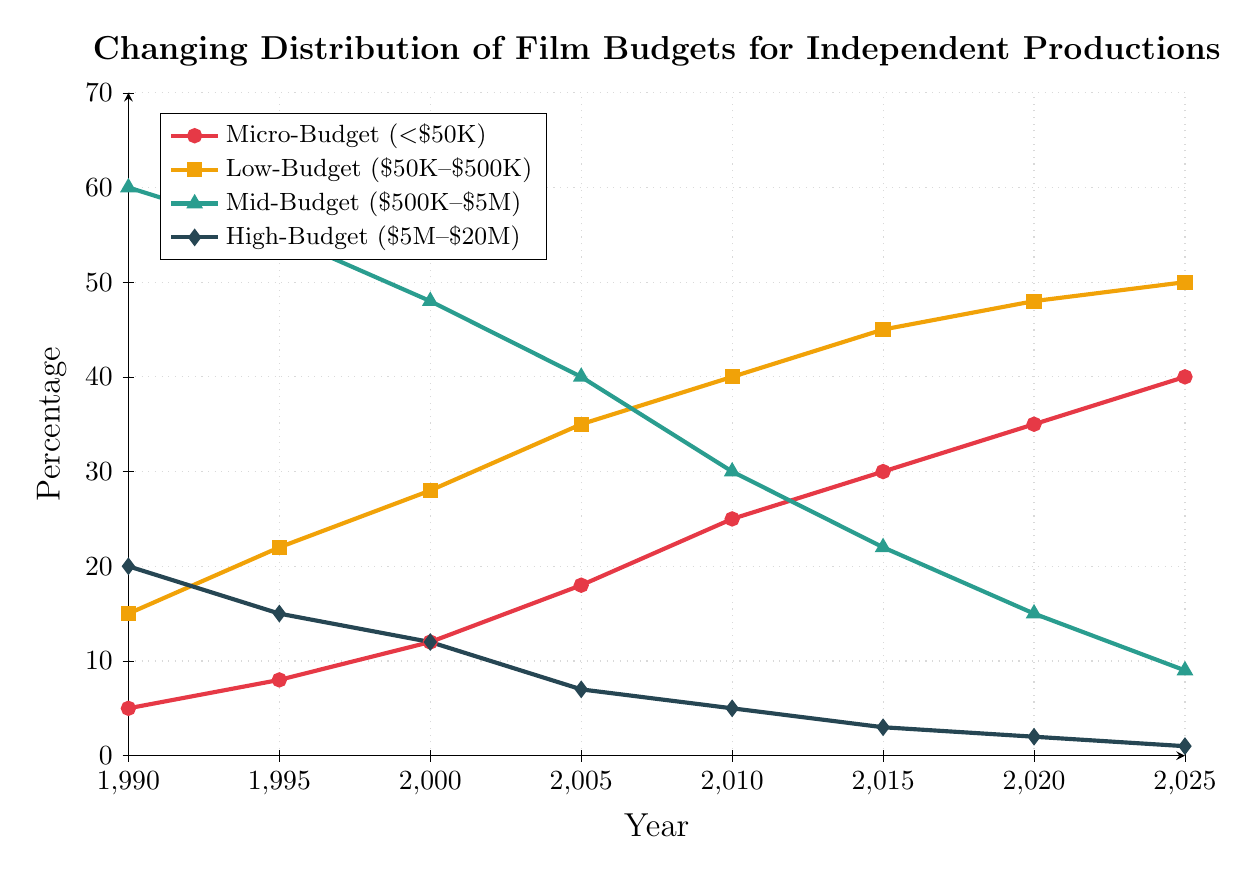Which budget category showed the highest percentage in 1990? The Mid-Budget category ($500K-$5M) showed the highest percentage in 1990, as it is represented by the green line standing at 60%.
Answer: Mid-Budget How did the percentage of High-Budget films change from 1990 to 2025? High-Budget films’ percentage dropped from 20% in 1990 to 1% in 2025. This decline is shown by the dark blue line moving downwards.
Answer: It decreased significantly What is the difference in the percentage of Low-Budget films between 1995 and 2025? In 1995, the percentage of Low-Budget films was 22%, while in 2025 it was 50%. The difference is 50 - 22.
Answer: 28% Which budget category showed the greatest increase from 1990 to 2025? The Micro-Budget category (<$50K) showed the greatest increase, rising from 5% in 1990 to 40% in 2025, reflected by the red line.
Answer: Micro-Budget What trend do you observe in Mid-Budget films from 1990 to 2025? The percentage of Mid-Budget films shows a consistent decrease from 60% in 1990 to 9% in 2025, as shown by the green line moving downwards.
Answer: Consistently decreasing In which year did the percentage of Micro-Budget films surpass that of Mid-Budget films? In 2005, the red line (Micro-Budget) surpassed the green line (Mid-Budget), with percentages of 18% and 40%, respectively.
Answer: 2005 Compare the change in percentage points of Low-Budget and High-Budget films between 2000 and 2020. The Low-Budget category increased from 28% to 48%, a change of 20 points. The High-Budget category decreased from 12% to 2%, a change of 10 points.
Answer: Low-Budget increased by 20 points, High-Budget decreased by 10 points What was the percentage of Low-Budget films in 2010 compared to High-Budget films? Low-Budget was at 40% while High-Budget was at 5%, as indicated by the yellow line (Low-Budget) and dark blue line (High-Budget) in 2010.
Answer: Low-Budget 40%, High-Budget 5% Which budget category is consistently the lowest throughout the timeline? The High-Budget category ($5M-$20M) consistently shows the lowest percentage throughout the years, as represented by the dark blue line.
Answer: High-Budget 